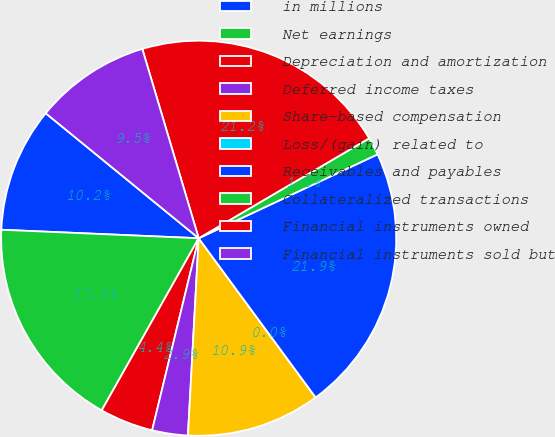Convert chart. <chart><loc_0><loc_0><loc_500><loc_500><pie_chart><fcel>in millions<fcel>Net earnings<fcel>Depreciation and amortization<fcel>Deferred income taxes<fcel>Share-based compensation<fcel>Loss/(gain) related to<fcel>Receivables and payables<fcel>Collateralized transactions<fcel>Financial instruments owned<fcel>Financial instruments sold but<nl><fcel>10.22%<fcel>17.52%<fcel>4.38%<fcel>2.92%<fcel>10.95%<fcel>0.0%<fcel>21.9%<fcel>1.46%<fcel>21.17%<fcel>9.49%<nl></chart> 